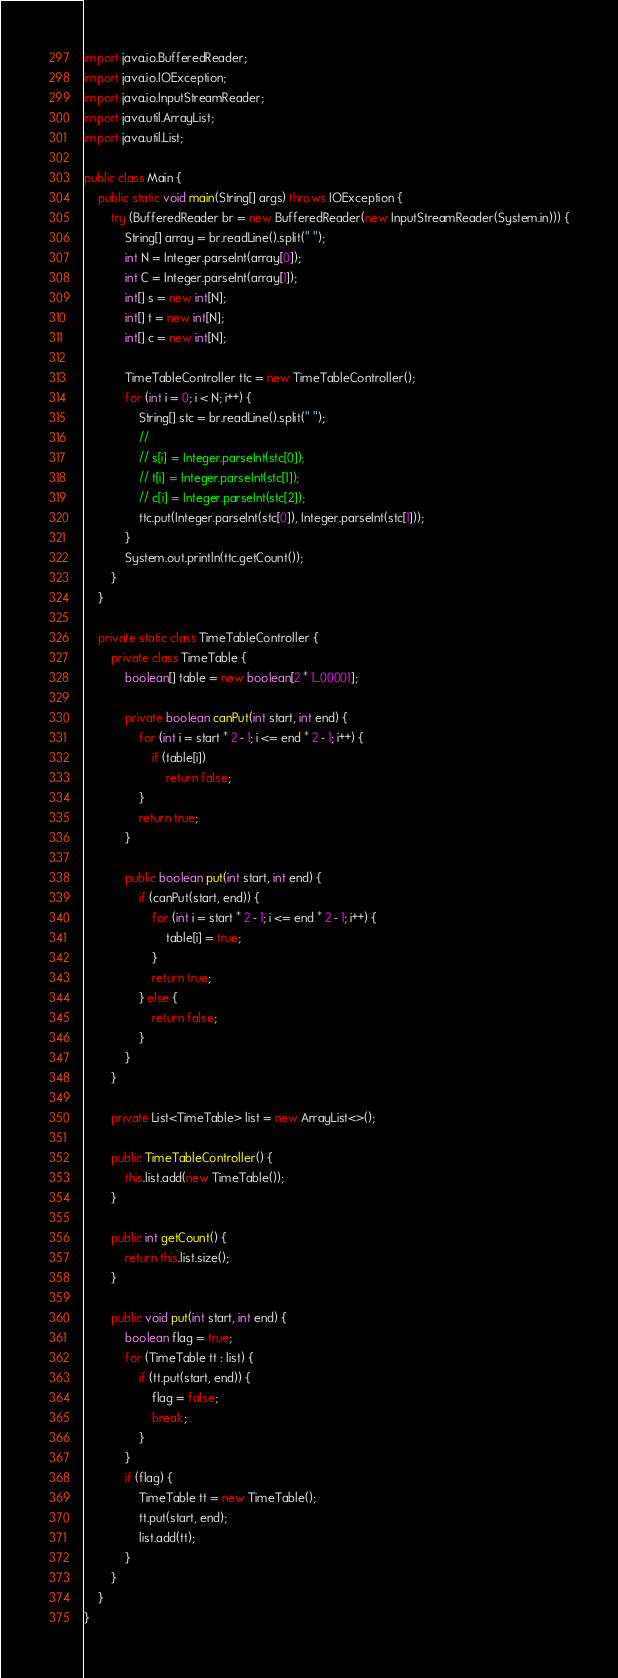Convert code to text. <code><loc_0><loc_0><loc_500><loc_500><_Java_>import java.io.BufferedReader;
import java.io.IOException;
import java.io.InputStreamReader;
import java.util.ArrayList;
import java.util.List;

public class Main {
	public static void main(String[] args) throws IOException {
		try (BufferedReader br = new BufferedReader(new InputStreamReader(System.in))) {
			String[] array = br.readLine().split(" ");
			int N = Integer.parseInt(array[0]);
			int C = Integer.parseInt(array[1]);
			int[] s = new int[N];
			int[] t = new int[N];
			int[] c = new int[N];

			TimeTableController ttc = new TimeTableController();
			for (int i = 0; i < N; i++) {
				String[] stc = br.readLine().split(" ");
				//
				// s[i] = Integer.parseInt(stc[0]);
				// t[i] = Integer.parseInt(stc[1]);
				// c[i] = Integer.parseInt(stc[2]);
				ttc.put(Integer.parseInt(stc[0]), Integer.parseInt(stc[1]));
			}
			System.out.println(ttc.getCount());
		}
	}

	private static class TimeTableController {
		private class TimeTable {
			boolean[] table = new boolean[2 * 1_00001];

			private boolean canPut(int start, int end) {
				for (int i = start * 2 - 1; i <= end * 2 - 1; i++) {
					if (table[i])
						return false;
				}
				return true;
			}

			public boolean put(int start, int end) {
				if (canPut(start, end)) {
					for (int i = start * 2 - 1; i <= end * 2 - 1; i++) {
						table[i] = true;
					}
					return true;
				} else {
					return false;
				}
			}
		}

		private List<TimeTable> list = new ArrayList<>();

		public TimeTableController() {
			this.list.add(new TimeTable());
		}

		public int getCount() {
			return this.list.size();
		}

		public void put(int start, int end) {
			boolean flag = true;
			for (TimeTable tt : list) {
				if (tt.put(start, end)) {
					flag = false;
					break;
				}
			}
			if (flag) {
				TimeTable tt = new TimeTable();
				tt.put(start, end);
				list.add(tt);
			}
		}
	}
}
</code> 